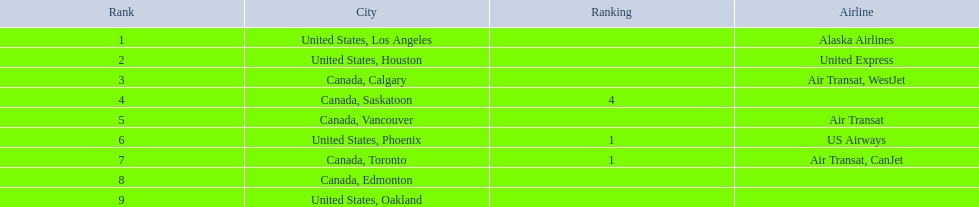What cities do the planes fly to? United States, Los Angeles, United States, Houston, Canada, Calgary, Canada, Saskatoon, Canada, Vancouver, United States, Phoenix, Canada, Toronto, Canada, Edmonton, United States, Oakland. How many people are flying to phoenix, arizona? 1,829. 